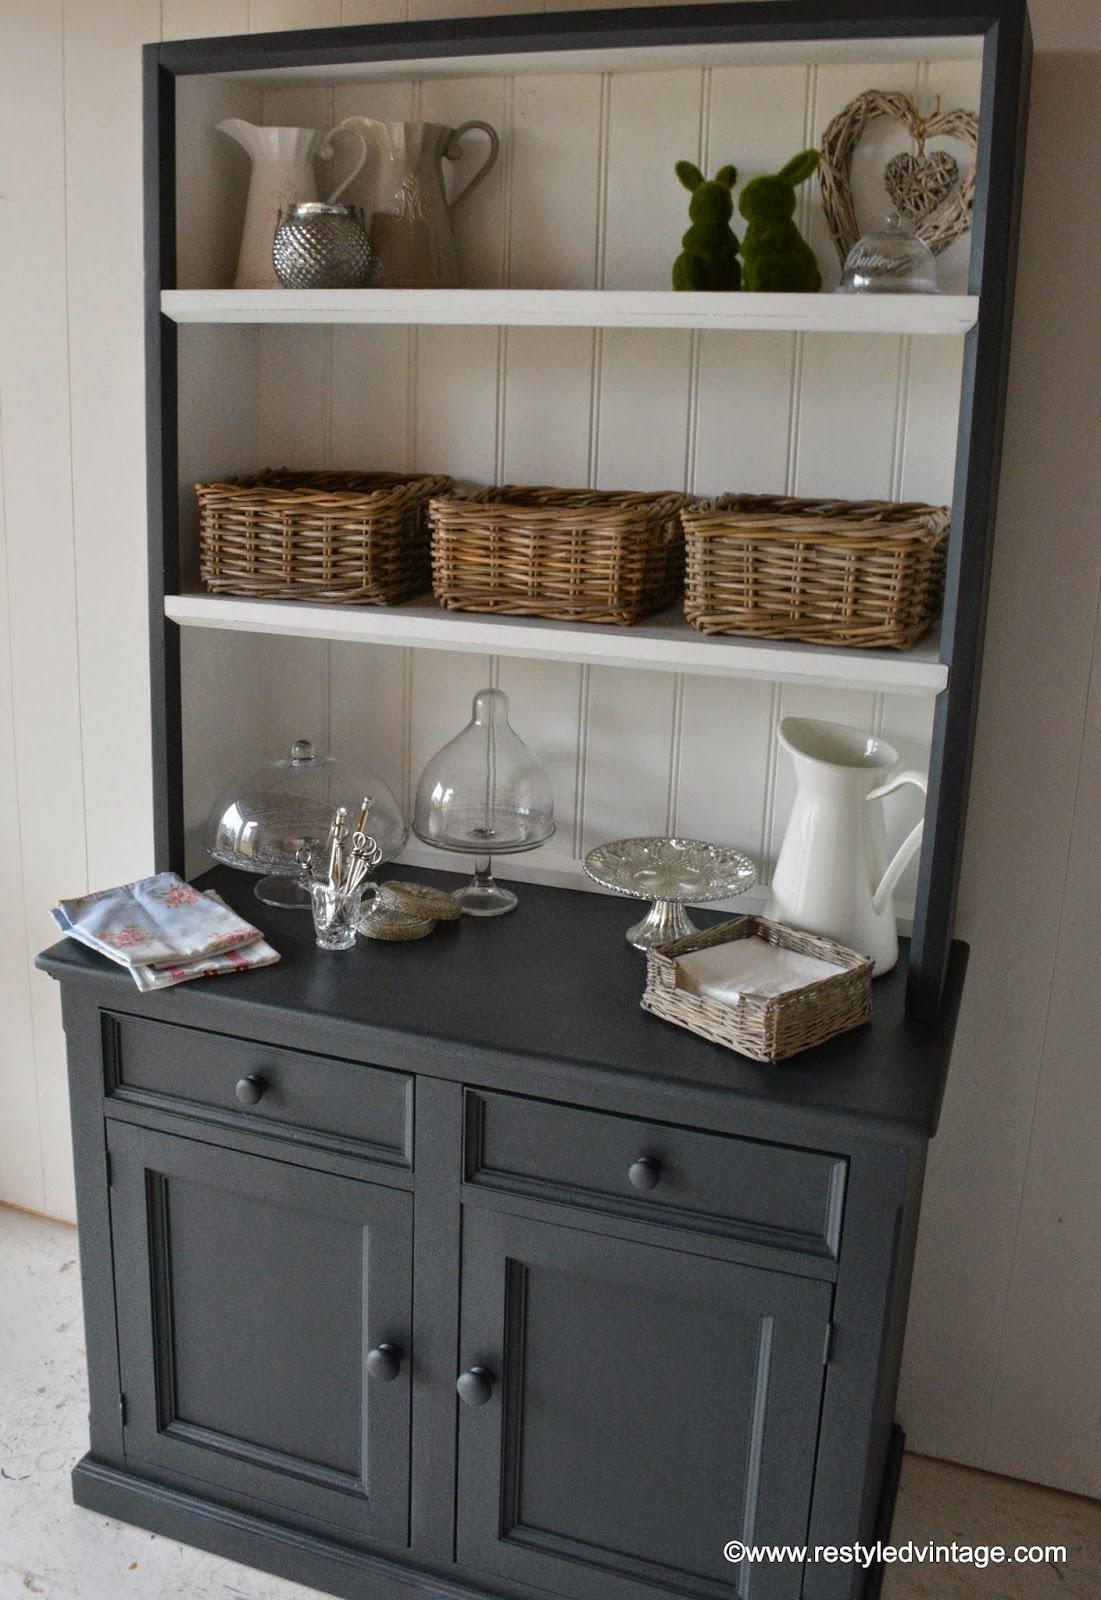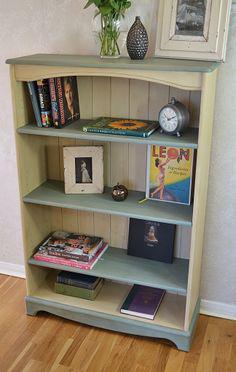The first image is the image on the left, the second image is the image on the right. Given the left and right images, does the statement "In one image a bookshelf with four levels has a decorative inner arc framing the upper shelf on which a clock is sitting." hold true? Answer yes or no. Yes. 